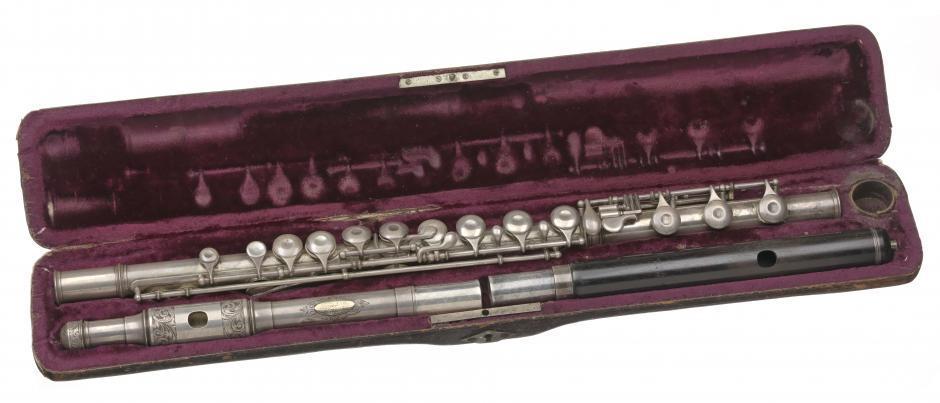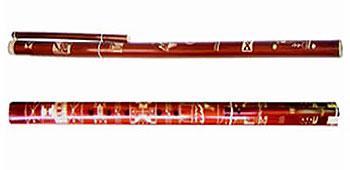The first image is the image on the left, the second image is the image on the right. Assess this claim about the two images: "Each image includes an open case for an instrument, and in at least one image, an instrument is fully inside the case.". Correct or not? Answer yes or no. No. The first image is the image on the left, the second image is the image on the right. Considering the images on both sides, is "Each image shows instruments in or with a case." valid? Answer yes or no. No. 